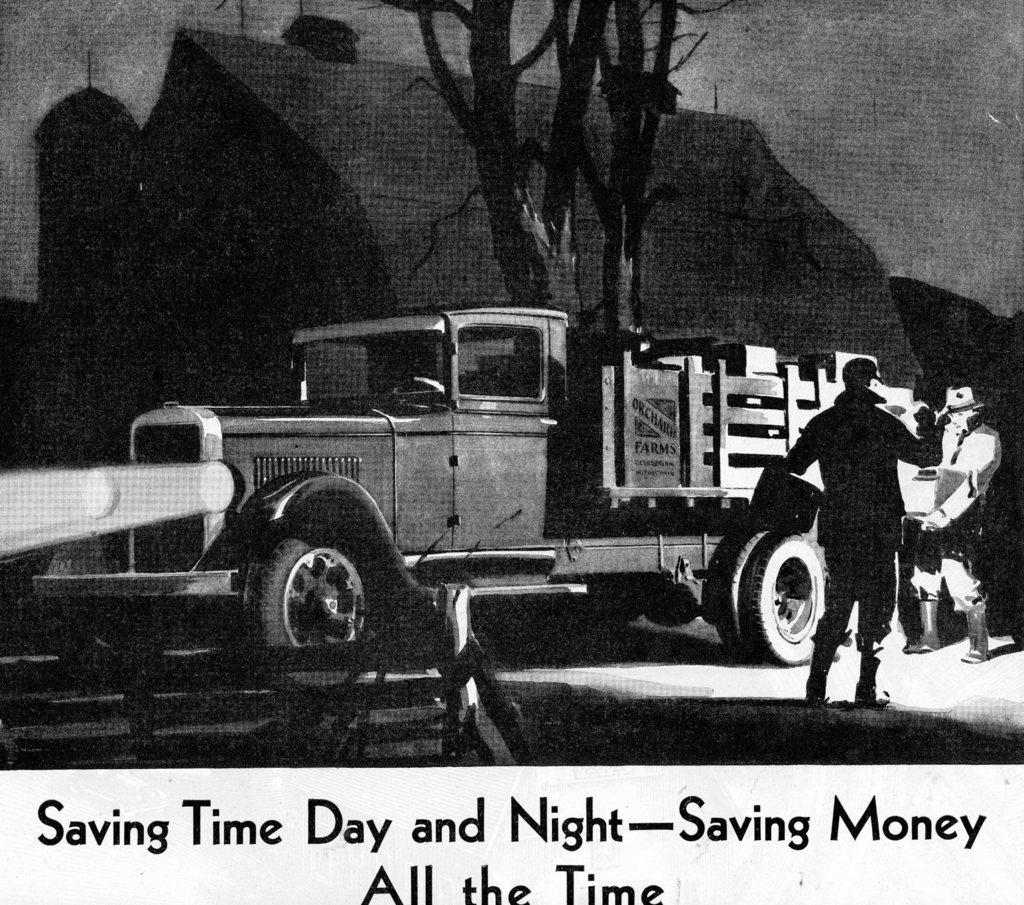Can you describe this image briefly? This is an animated picture where we can a truck and two persons are standing. Behind truck one house and tree is present. Downside of the image some text is written. 